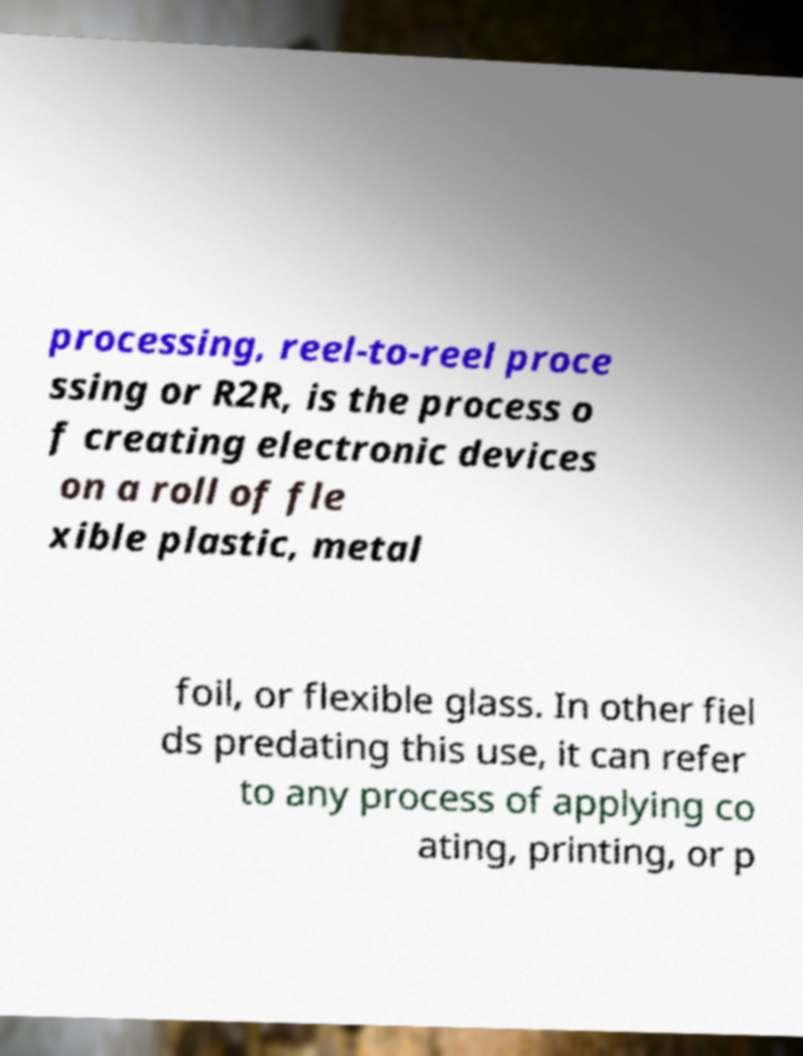There's text embedded in this image that I need extracted. Can you transcribe it verbatim? processing, reel-to-reel proce ssing or R2R, is the process o f creating electronic devices on a roll of fle xible plastic, metal foil, or flexible glass. In other fiel ds predating this use, it can refer to any process of applying co ating, printing, or p 